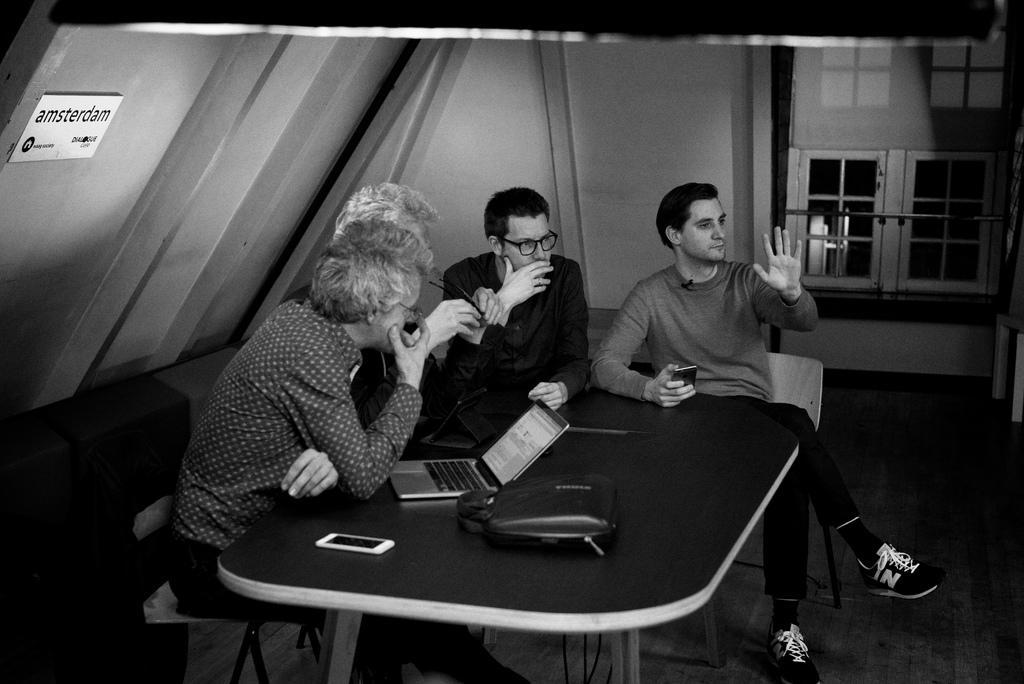How would you summarize this image in a sentence or two? It looks like a black and white image. We can see there are four people sitting on chairs. In front of the people there is a table and on the table there is a mobile, laptop and some objects. On the left side of the image, there is a board on the wall. On the right side of the image there are windows. 